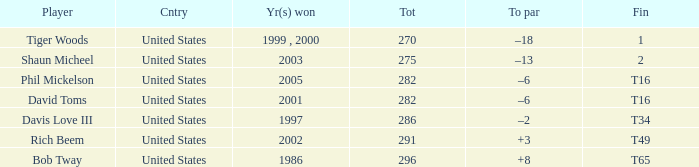Parse the table in full. {'header': ['Player', 'Cntry', 'Yr(s) won', 'Tot', 'To par', 'Fin'], 'rows': [['Tiger Woods', 'United States', '1999 , 2000', '270', '–18', '1'], ['Shaun Micheel', 'United States', '2003', '275', '–13', '2'], ['Phil Mickelson', 'United States', '2005', '282', '–6', 'T16'], ['David Toms', 'United States', '2001', '282', '–6', 'T16'], ['Davis Love III', 'United States', '1997', '286', '–2', 'T34'], ['Rich Beem', 'United States', '2002', '291', '+3', 'T49'], ['Bob Tway', 'United States', '1986', '296', '+8', 'T65']]} In which year(s) did the person who has a total of 291 win? 2002.0. 